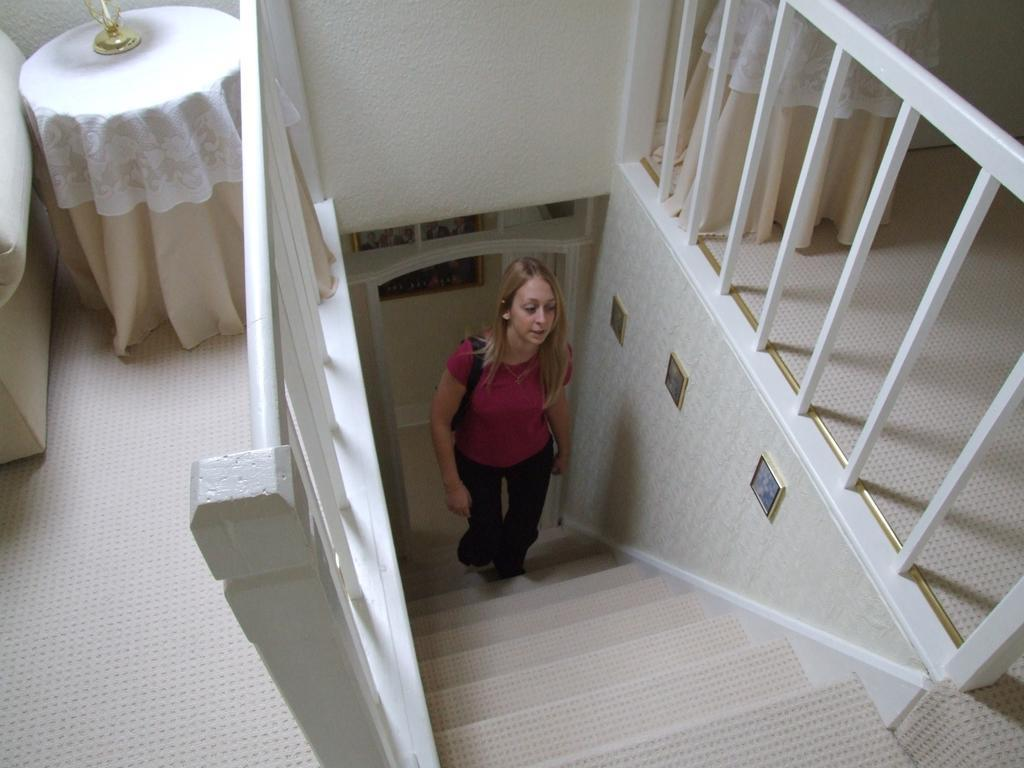Who is present in the image? There is a woman in the image. What is the woman wearing? The woman is wearing clothes. What is the woman doing in the image? The woman is climbing stairs. What can be seen in the background of the image? There is a fence in the image. What objects are present in the image? There is a table and a lamp in the image. What type of surface is the woman standing on? There is a floor in the image, which is the surface the woman is standing on. What is the texture of the crime scene in the image? There is no crime scene present in the image, so it is not possible to determine the texture. 